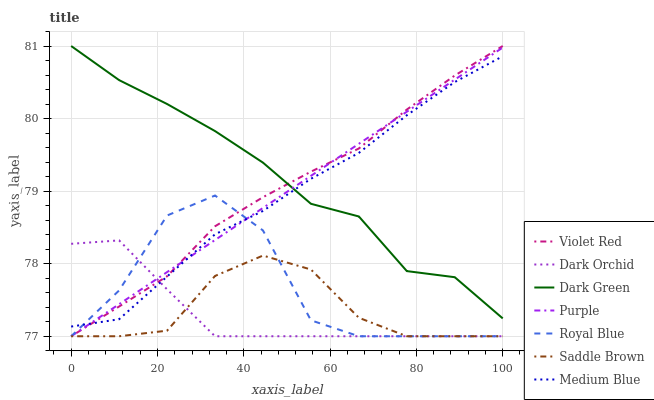Does Dark Orchid have the minimum area under the curve?
Answer yes or no. Yes. Does Dark Green have the maximum area under the curve?
Answer yes or no. Yes. Does Purple have the minimum area under the curve?
Answer yes or no. No. Does Purple have the maximum area under the curve?
Answer yes or no. No. Is Purple the smoothest?
Answer yes or no. Yes. Is Royal Blue the roughest?
Answer yes or no. Yes. Is Medium Blue the smoothest?
Answer yes or no. No. Is Medium Blue the roughest?
Answer yes or no. No. Does Violet Red have the lowest value?
Answer yes or no. Yes. Does Medium Blue have the lowest value?
Answer yes or no. No. Does Dark Green have the highest value?
Answer yes or no. Yes. Does Purple have the highest value?
Answer yes or no. No. Is Saddle Brown less than Medium Blue?
Answer yes or no. Yes. Is Dark Green greater than Royal Blue?
Answer yes or no. Yes. Does Dark Orchid intersect Saddle Brown?
Answer yes or no. Yes. Is Dark Orchid less than Saddle Brown?
Answer yes or no. No. Is Dark Orchid greater than Saddle Brown?
Answer yes or no. No. Does Saddle Brown intersect Medium Blue?
Answer yes or no. No. 